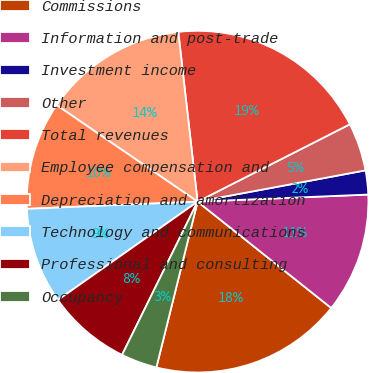Convert chart. <chart><loc_0><loc_0><loc_500><loc_500><pie_chart><fcel>Commissions<fcel>Information and post-trade<fcel>Investment income<fcel>Other<fcel>Total revenues<fcel>Employee compensation and<fcel>Depreciation and amortization<fcel>Technology and communications<fcel>Professional and consulting<fcel>Occupancy<nl><fcel>18.18%<fcel>11.36%<fcel>2.27%<fcel>4.55%<fcel>19.32%<fcel>13.64%<fcel>10.23%<fcel>9.09%<fcel>7.95%<fcel>3.41%<nl></chart> 